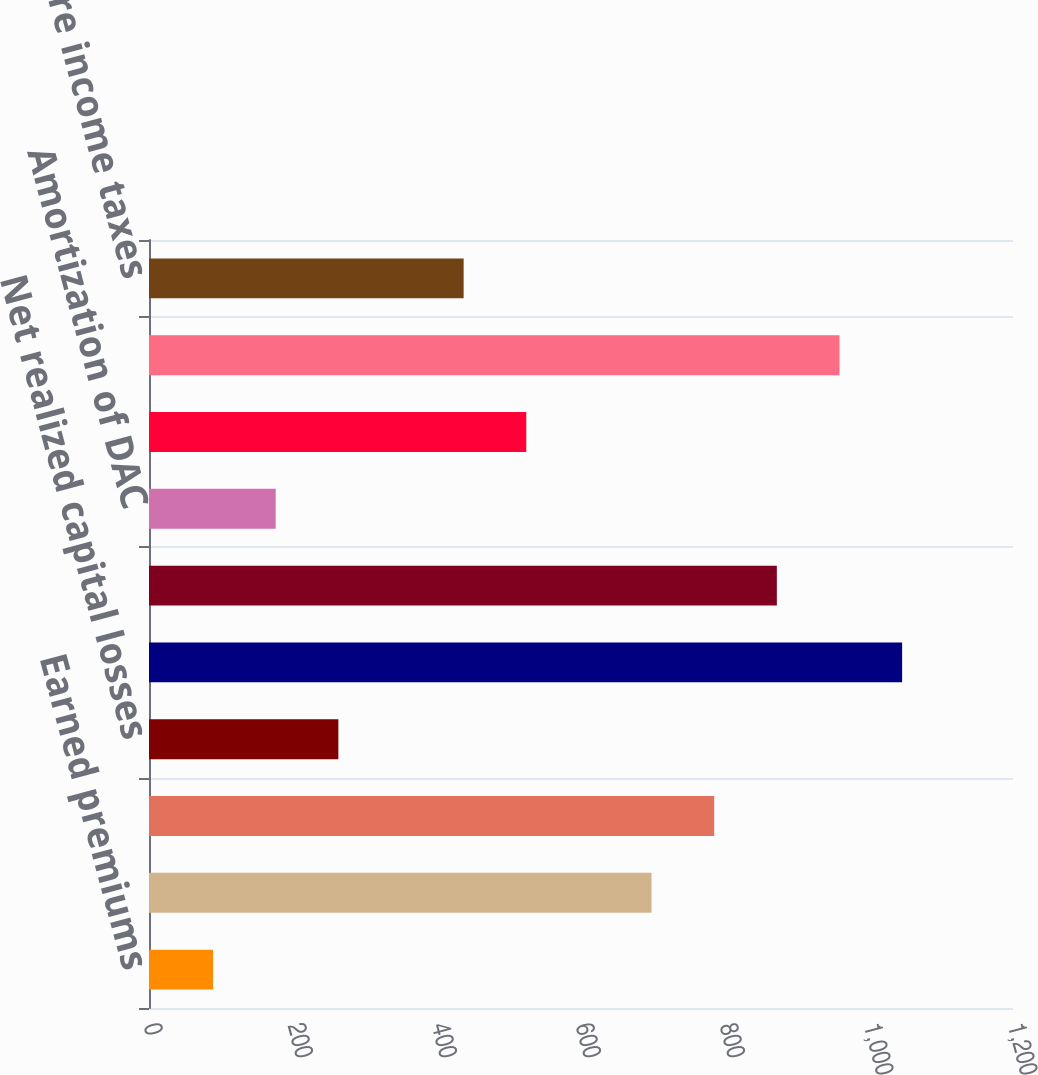Convert chart to OTSL. <chart><loc_0><loc_0><loc_500><loc_500><bar_chart><fcel>Earned premiums<fcel>Fee income and other<fcel>Net investment income<fcel>Net realized capital losses<fcel>Total revenues<fcel>Benefits losses and loss<fcel>Amortization of DAC<fcel>Insurance operating costs and<fcel>Total benefits losses and<fcel>Income before income taxes<nl><fcel>89<fcel>698<fcel>785<fcel>263<fcel>1046<fcel>872<fcel>176<fcel>524<fcel>959<fcel>437<nl></chart> 